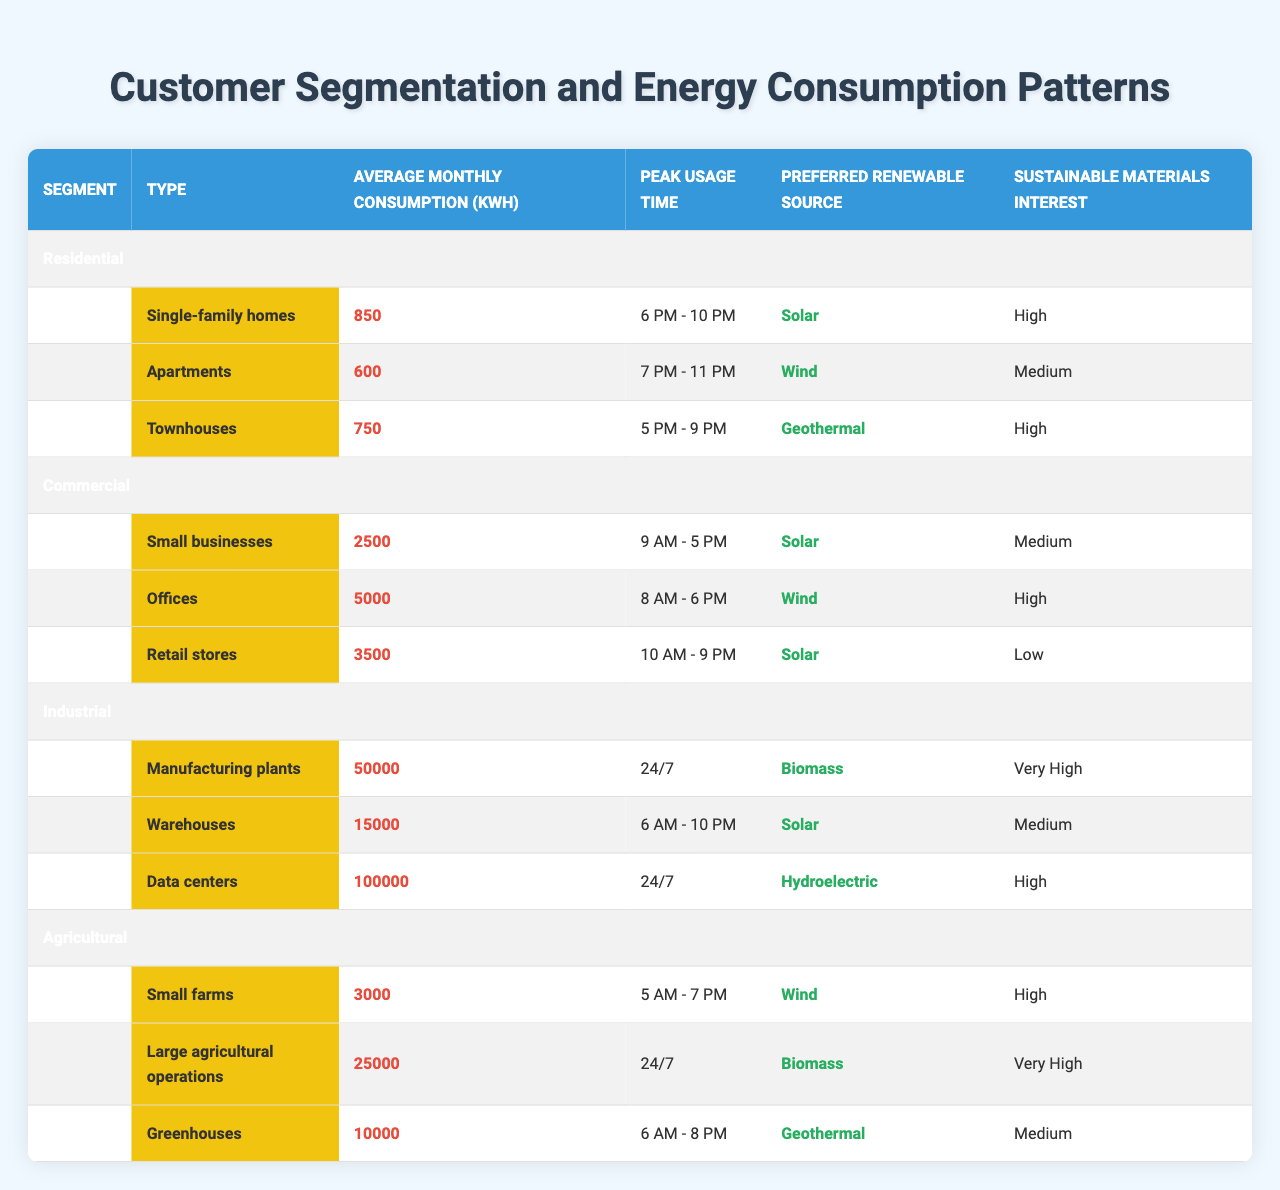What is the average monthly consumption for residential apartments? The table lists the average monthly consumption for residential apartments as 600 kWh.
Answer: 600 kWh Which segment has the highest average monthly consumption? The industrial segment has the highest average monthly consumption, with data points like 50,000 kWh for manufacturing plants and 100,000 kWh for data centers.
Answer: Industrial Are small businesses more likely to prefer solar or wind energy? Small businesses prefer solar energy, as their preferred renewable source is solar, while large businesses like offices prefer wind energy.
Answer: Solar What is the peak usage time for townhouses? The peak usage time for townhouses is recorded as 5 PM to 9 PM.
Answer: 5 PM - 9 PM What is the total average monthly consumption for the commercial segment? Adding the average monthly consumption for all sub-segments in commercial (2500 + 5000 + 3500) gives a total of 11000 kWh.
Answer: 11000 kWh Do townhouses have a higher average monthly consumption than single-family homes? Yes, single-family homes consume an average of 850 kWh, while townhouses consume 750 kWh, indicating townhouses consume less on average.
Answer: No Which renewable source is preferred by the majority of the agricultural sub-segments? In the agricultural sub-segments, small farms prefer wind, large agricultural operations prefer biomass, and greenhouses prefer geothermal, indicating no single preferred source across all.
Answer: No single source What is the sustainable materials interest of data centers? The sustainable materials interest of data centers is classified as high in the table.
Answer: High What is the difference in average monthly consumption between offices and large agricultural operations? Offices consume 5000 kWh, while large agricultural operations consume 25000 kWh; the difference is 25000 - 5000 = 20000 kWh.
Answer: 20000 kWh Which segment shows the highest interest in sustainable materials? The industrial segment, specifically manufacturing plants, shows very high interest in sustainable materials.
Answer: Industrial What is the preferred renewable source for warehouses? Warehouses have solar as their preferred renewable source.
Answer: Solar 